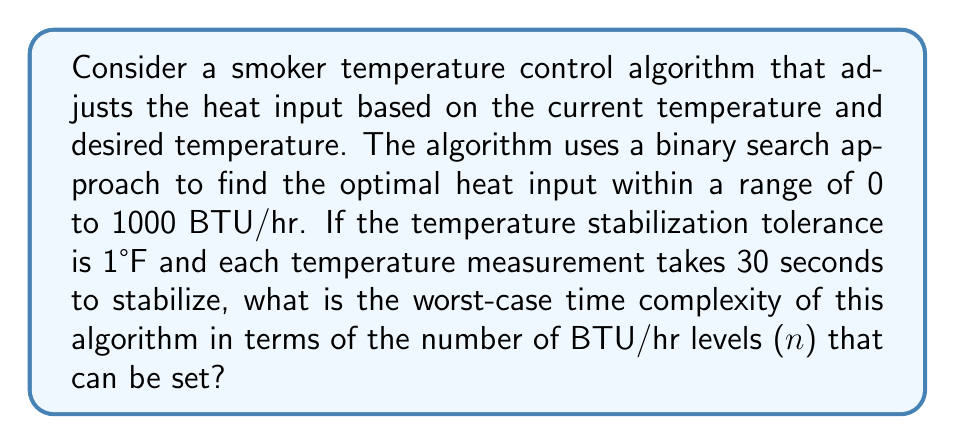What is the answer to this math problem? To analyze the time complexity of this smoker temperature control algorithm, we need to consider the following steps:

1. The algorithm uses a binary search approach, which has a time complexity of $O(\log n)$ where $n$ is the number of elements in the search space.

2. In this case, the search space is the range of heat input levels from 0 to 1000 BTU/hr. Let's assume there are $n$ discrete levels within this range.

3. For each iteration of the binary search:
   a. The algorithm sets a new heat input level
   b. It waits for the temperature to stabilize (30 seconds)
   c. It compares the current temperature with the desired temperature

4. The binary search continues until the temperature is within the 1°F tolerance of the desired temperature.

5. In the worst-case scenario, the binary search will make $\log_2 n$ comparisons.

6. Each comparison involves waiting for 30 seconds for the temperature to stabilize.

Therefore, the worst-case time complexity can be expressed as:

$$T(n) = 30 \cdot \log_2 n$$

Where $T(n)$ is the time in seconds, and $n$ is the number of possible heat input levels.

In Big O notation, we drop constants, so the time complexity is $O(\log n)$.

However, it's important to note that this is not a typical computational complexity, as it involves real-time measurements. The actual running time depends on the physical process of temperature stabilization, which is significantly slower than typical computer operations.
Answer: The worst-case time complexity of the smoker temperature control algorithm is $O(\log n)$, where $n$ is the number of possible heat input levels. 